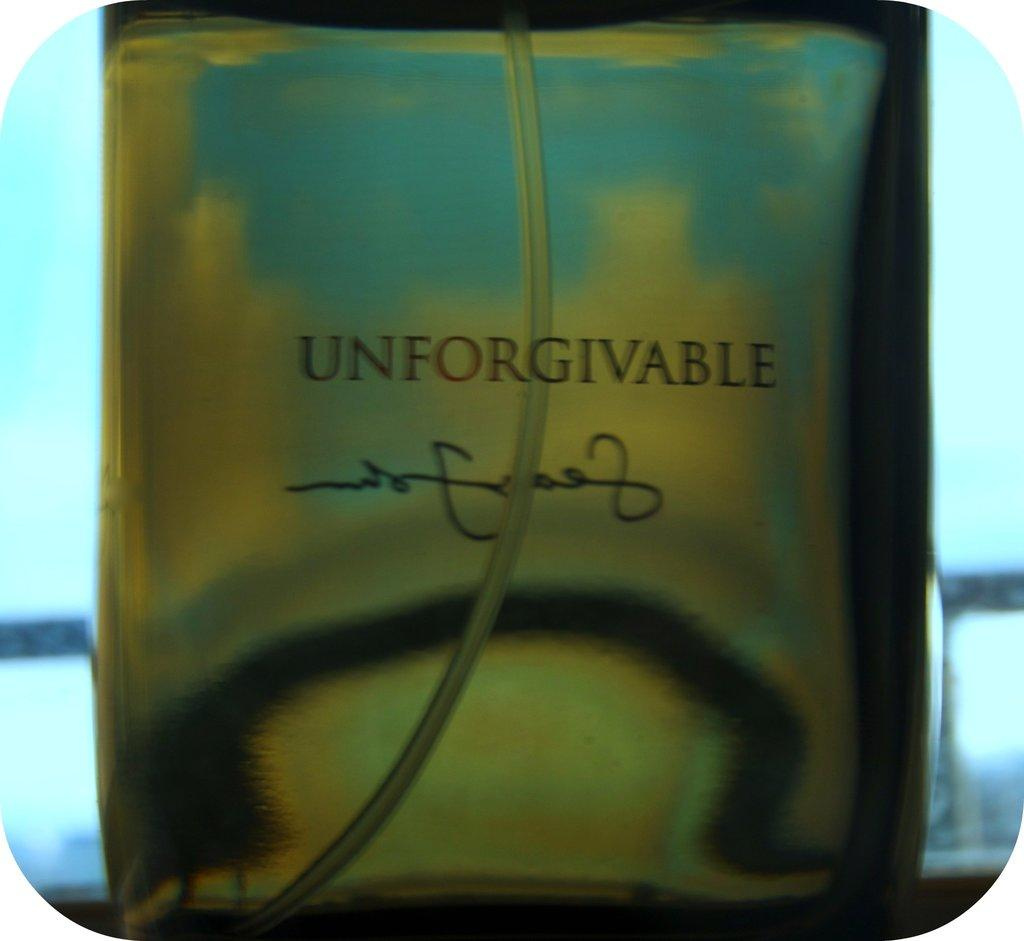Provide a one-sentence caption for the provided image. Aperfume bottle labeled unforgivable with the tube for the pump nozzle in it. 